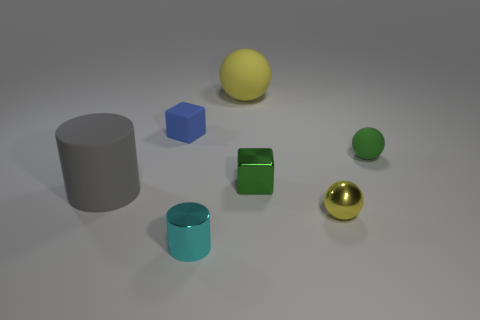Subtract all tiny spheres. How many spheres are left? 1 Subtract 2 cylinders. How many cylinders are left? 0 Subtract all cylinders. How many objects are left? 5 Subtract all gray cylinders. How many cylinders are left? 1 Add 1 large gray things. How many objects exist? 8 Subtract 0 blue balls. How many objects are left? 7 Subtract all gray spheres. Subtract all gray blocks. How many spheres are left? 3 Subtract all brown cylinders. How many blue balls are left? 0 Subtract all gray metallic spheres. Subtract all small green metal objects. How many objects are left? 6 Add 2 green rubber things. How many green rubber things are left? 3 